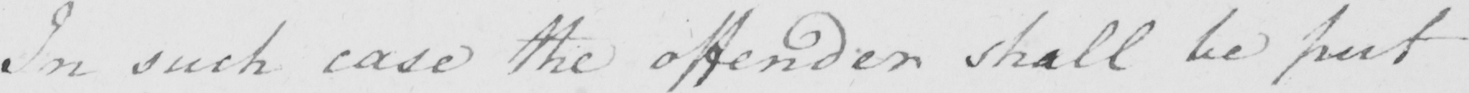What does this handwritten line say? In such case the offender shall be put 